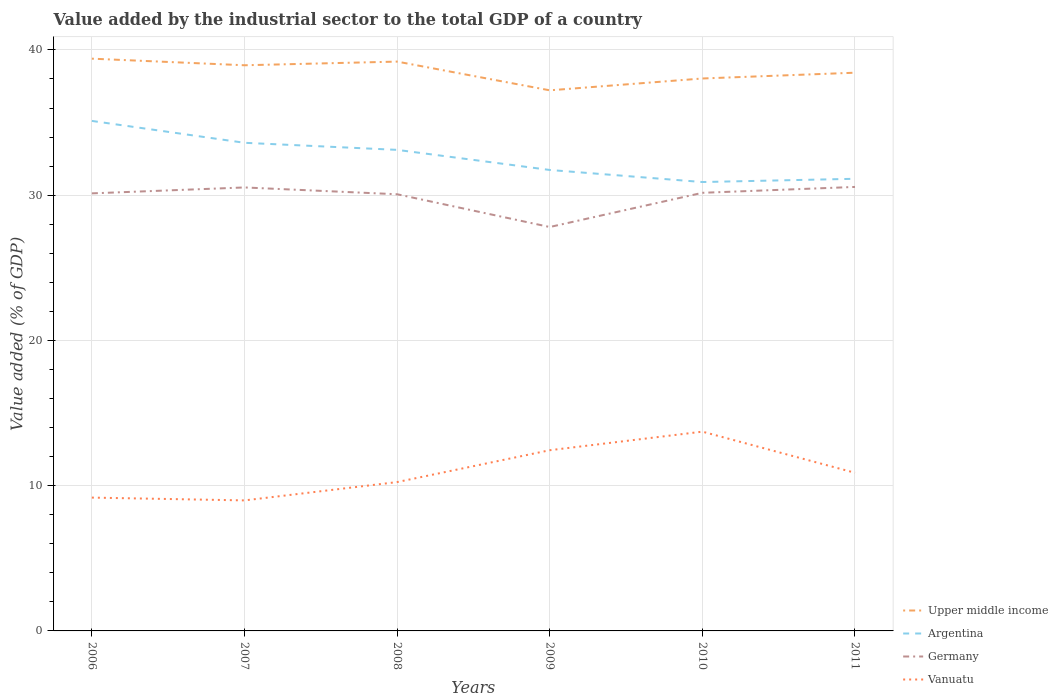Does the line corresponding to Argentina intersect with the line corresponding to Upper middle income?
Your response must be concise. No. Is the number of lines equal to the number of legend labels?
Offer a terse response. Yes. Across all years, what is the maximum value added by the industrial sector to the total GDP in Upper middle income?
Provide a succinct answer. 37.22. What is the total value added by the industrial sector to the total GDP in Upper middle income in the graph?
Your answer should be compact. 0.91. What is the difference between the highest and the second highest value added by the industrial sector to the total GDP in Upper middle income?
Ensure brevity in your answer.  2.18. Is the value added by the industrial sector to the total GDP in Germany strictly greater than the value added by the industrial sector to the total GDP in Argentina over the years?
Provide a succinct answer. Yes. How many lines are there?
Keep it short and to the point. 4. Are the values on the major ticks of Y-axis written in scientific E-notation?
Provide a succinct answer. No. Does the graph contain any zero values?
Your answer should be very brief. No. How many legend labels are there?
Ensure brevity in your answer.  4. What is the title of the graph?
Keep it short and to the point. Value added by the industrial sector to the total GDP of a country. What is the label or title of the X-axis?
Your response must be concise. Years. What is the label or title of the Y-axis?
Give a very brief answer. Value added (% of GDP). What is the Value added (% of GDP) of Upper middle income in 2006?
Offer a terse response. 39.4. What is the Value added (% of GDP) of Argentina in 2006?
Your answer should be very brief. 35.11. What is the Value added (% of GDP) in Germany in 2006?
Ensure brevity in your answer.  30.12. What is the Value added (% of GDP) in Vanuatu in 2006?
Your answer should be very brief. 9.18. What is the Value added (% of GDP) of Upper middle income in 2007?
Give a very brief answer. 38.94. What is the Value added (% of GDP) in Argentina in 2007?
Your response must be concise. 33.61. What is the Value added (% of GDP) in Germany in 2007?
Ensure brevity in your answer.  30.53. What is the Value added (% of GDP) in Vanuatu in 2007?
Your answer should be very brief. 8.99. What is the Value added (% of GDP) in Upper middle income in 2008?
Ensure brevity in your answer.  39.2. What is the Value added (% of GDP) in Argentina in 2008?
Your answer should be very brief. 33.12. What is the Value added (% of GDP) of Germany in 2008?
Offer a very short reply. 30.06. What is the Value added (% of GDP) in Vanuatu in 2008?
Keep it short and to the point. 10.25. What is the Value added (% of GDP) of Upper middle income in 2009?
Offer a very short reply. 37.22. What is the Value added (% of GDP) in Argentina in 2009?
Your answer should be very brief. 31.74. What is the Value added (% of GDP) in Germany in 2009?
Ensure brevity in your answer.  27.81. What is the Value added (% of GDP) of Vanuatu in 2009?
Give a very brief answer. 12.44. What is the Value added (% of GDP) of Upper middle income in 2010?
Keep it short and to the point. 38.03. What is the Value added (% of GDP) in Argentina in 2010?
Keep it short and to the point. 30.9. What is the Value added (% of GDP) of Germany in 2010?
Provide a short and direct response. 30.16. What is the Value added (% of GDP) in Vanuatu in 2010?
Offer a terse response. 13.72. What is the Value added (% of GDP) in Upper middle income in 2011?
Your answer should be compact. 38.43. What is the Value added (% of GDP) of Argentina in 2011?
Your answer should be compact. 31.13. What is the Value added (% of GDP) in Germany in 2011?
Make the answer very short. 30.57. What is the Value added (% of GDP) in Vanuatu in 2011?
Your answer should be compact. 10.89. Across all years, what is the maximum Value added (% of GDP) of Upper middle income?
Offer a very short reply. 39.4. Across all years, what is the maximum Value added (% of GDP) of Argentina?
Your answer should be compact. 35.11. Across all years, what is the maximum Value added (% of GDP) of Germany?
Give a very brief answer. 30.57. Across all years, what is the maximum Value added (% of GDP) of Vanuatu?
Ensure brevity in your answer.  13.72. Across all years, what is the minimum Value added (% of GDP) of Upper middle income?
Give a very brief answer. 37.22. Across all years, what is the minimum Value added (% of GDP) of Argentina?
Provide a succinct answer. 30.9. Across all years, what is the minimum Value added (% of GDP) of Germany?
Make the answer very short. 27.81. Across all years, what is the minimum Value added (% of GDP) in Vanuatu?
Ensure brevity in your answer.  8.99. What is the total Value added (% of GDP) in Upper middle income in the graph?
Your answer should be very brief. 231.22. What is the total Value added (% of GDP) of Argentina in the graph?
Provide a short and direct response. 195.6. What is the total Value added (% of GDP) in Germany in the graph?
Offer a very short reply. 179.26. What is the total Value added (% of GDP) of Vanuatu in the graph?
Provide a short and direct response. 65.46. What is the difference between the Value added (% of GDP) of Upper middle income in 2006 and that in 2007?
Provide a succinct answer. 0.45. What is the difference between the Value added (% of GDP) of Argentina in 2006 and that in 2007?
Keep it short and to the point. 1.51. What is the difference between the Value added (% of GDP) of Germany in 2006 and that in 2007?
Provide a short and direct response. -0.41. What is the difference between the Value added (% of GDP) of Vanuatu in 2006 and that in 2007?
Offer a terse response. 0.19. What is the difference between the Value added (% of GDP) in Upper middle income in 2006 and that in 2008?
Your response must be concise. 0.2. What is the difference between the Value added (% of GDP) of Argentina in 2006 and that in 2008?
Your answer should be compact. 1.99. What is the difference between the Value added (% of GDP) in Germany in 2006 and that in 2008?
Offer a very short reply. 0.06. What is the difference between the Value added (% of GDP) of Vanuatu in 2006 and that in 2008?
Offer a terse response. -1.07. What is the difference between the Value added (% of GDP) of Upper middle income in 2006 and that in 2009?
Offer a terse response. 2.18. What is the difference between the Value added (% of GDP) in Argentina in 2006 and that in 2009?
Your response must be concise. 3.38. What is the difference between the Value added (% of GDP) of Germany in 2006 and that in 2009?
Make the answer very short. 2.32. What is the difference between the Value added (% of GDP) in Vanuatu in 2006 and that in 2009?
Provide a short and direct response. -3.26. What is the difference between the Value added (% of GDP) in Upper middle income in 2006 and that in 2010?
Give a very brief answer. 1.36. What is the difference between the Value added (% of GDP) of Argentina in 2006 and that in 2010?
Give a very brief answer. 4.21. What is the difference between the Value added (% of GDP) in Germany in 2006 and that in 2010?
Make the answer very short. -0.04. What is the difference between the Value added (% of GDP) of Vanuatu in 2006 and that in 2010?
Keep it short and to the point. -4.54. What is the difference between the Value added (% of GDP) of Upper middle income in 2006 and that in 2011?
Give a very brief answer. 0.97. What is the difference between the Value added (% of GDP) of Argentina in 2006 and that in 2011?
Offer a very short reply. 3.98. What is the difference between the Value added (% of GDP) of Germany in 2006 and that in 2011?
Ensure brevity in your answer.  -0.44. What is the difference between the Value added (% of GDP) of Vanuatu in 2006 and that in 2011?
Your answer should be compact. -1.71. What is the difference between the Value added (% of GDP) of Upper middle income in 2007 and that in 2008?
Ensure brevity in your answer.  -0.25. What is the difference between the Value added (% of GDP) in Argentina in 2007 and that in 2008?
Offer a very short reply. 0.49. What is the difference between the Value added (% of GDP) of Germany in 2007 and that in 2008?
Provide a short and direct response. 0.47. What is the difference between the Value added (% of GDP) in Vanuatu in 2007 and that in 2008?
Make the answer very short. -1.26. What is the difference between the Value added (% of GDP) of Upper middle income in 2007 and that in 2009?
Ensure brevity in your answer.  1.73. What is the difference between the Value added (% of GDP) in Argentina in 2007 and that in 2009?
Give a very brief answer. 1.87. What is the difference between the Value added (% of GDP) in Germany in 2007 and that in 2009?
Offer a terse response. 2.72. What is the difference between the Value added (% of GDP) of Vanuatu in 2007 and that in 2009?
Provide a succinct answer. -3.45. What is the difference between the Value added (% of GDP) in Upper middle income in 2007 and that in 2010?
Offer a very short reply. 0.91. What is the difference between the Value added (% of GDP) of Argentina in 2007 and that in 2010?
Make the answer very short. 2.7. What is the difference between the Value added (% of GDP) of Germany in 2007 and that in 2010?
Keep it short and to the point. 0.37. What is the difference between the Value added (% of GDP) in Vanuatu in 2007 and that in 2010?
Ensure brevity in your answer.  -4.73. What is the difference between the Value added (% of GDP) of Upper middle income in 2007 and that in 2011?
Provide a succinct answer. 0.51. What is the difference between the Value added (% of GDP) of Argentina in 2007 and that in 2011?
Your answer should be compact. 2.48. What is the difference between the Value added (% of GDP) in Germany in 2007 and that in 2011?
Give a very brief answer. -0.04. What is the difference between the Value added (% of GDP) of Vanuatu in 2007 and that in 2011?
Your answer should be very brief. -1.9. What is the difference between the Value added (% of GDP) in Upper middle income in 2008 and that in 2009?
Keep it short and to the point. 1.98. What is the difference between the Value added (% of GDP) of Argentina in 2008 and that in 2009?
Ensure brevity in your answer.  1.38. What is the difference between the Value added (% of GDP) of Germany in 2008 and that in 2009?
Provide a succinct answer. 2.26. What is the difference between the Value added (% of GDP) of Vanuatu in 2008 and that in 2009?
Provide a succinct answer. -2.19. What is the difference between the Value added (% of GDP) in Upper middle income in 2008 and that in 2010?
Ensure brevity in your answer.  1.16. What is the difference between the Value added (% of GDP) of Argentina in 2008 and that in 2010?
Give a very brief answer. 2.22. What is the difference between the Value added (% of GDP) of Germany in 2008 and that in 2010?
Keep it short and to the point. -0.1. What is the difference between the Value added (% of GDP) in Vanuatu in 2008 and that in 2010?
Give a very brief answer. -3.47. What is the difference between the Value added (% of GDP) of Upper middle income in 2008 and that in 2011?
Give a very brief answer. 0.76. What is the difference between the Value added (% of GDP) in Argentina in 2008 and that in 2011?
Your answer should be compact. 1.99. What is the difference between the Value added (% of GDP) of Germany in 2008 and that in 2011?
Keep it short and to the point. -0.5. What is the difference between the Value added (% of GDP) of Vanuatu in 2008 and that in 2011?
Make the answer very short. -0.64. What is the difference between the Value added (% of GDP) in Upper middle income in 2009 and that in 2010?
Your answer should be very brief. -0.82. What is the difference between the Value added (% of GDP) of Argentina in 2009 and that in 2010?
Ensure brevity in your answer.  0.83. What is the difference between the Value added (% of GDP) in Germany in 2009 and that in 2010?
Your response must be concise. -2.35. What is the difference between the Value added (% of GDP) in Vanuatu in 2009 and that in 2010?
Offer a terse response. -1.28. What is the difference between the Value added (% of GDP) of Upper middle income in 2009 and that in 2011?
Your answer should be very brief. -1.21. What is the difference between the Value added (% of GDP) of Argentina in 2009 and that in 2011?
Offer a terse response. 0.61. What is the difference between the Value added (% of GDP) of Germany in 2009 and that in 2011?
Offer a very short reply. -2.76. What is the difference between the Value added (% of GDP) in Vanuatu in 2009 and that in 2011?
Your answer should be compact. 1.55. What is the difference between the Value added (% of GDP) of Upper middle income in 2010 and that in 2011?
Your response must be concise. -0.4. What is the difference between the Value added (% of GDP) in Argentina in 2010 and that in 2011?
Offer a terse response. -0.22. What is the difference between the Value added (% of GDP) of Germany in 2010 and that in 2011?
Keep it short and to the point. -0.4. What is the difference between the Value added (% of GDP) in Vanuatu in 2010 and that in 2011?
Your response must be concise. 2.83. What is the difference between the Value added (% of GDP) of Upper middle income in 2006 and the Value added (% of GDP) of Argentina in 2007?
Offer a terse response. 5.79. What is the difference between the Value added (% of GDP) of Upper middle income in 2006 and the Value added (% of GDP) of Germany in 2007?
Your answer should be compact. 8.87. What is the difference between the Value added (% of GDP) of Upper middle income in 2006 and the Value added (% of GDP) of Vanuatu in 2007?
Keep it short and to the point. 30.41. What is the difference between the Value added (% of GDP) of Argentina in 2006 and the Value added (% of GDP) of Germany in 2007?
Ensure brevity in your answer.  4.58. What is the difference between the Value added (% of GDP) of Argentina in 2006 and the Value added (% of GDP) of Vanuatu in 2007?
Provide a short and direct response. 26.13. What is the difference between the Value added (% of GDP) of Germany in 2006 and the Value added (% of GDP) of Vanuatu in 2007?
Ensure brevity in your answer.  21.14. What is the difference between the Value added (% of GDP) of Upper middle income in 2006 and the Value added (% of GDP) of Argentina in 2008?
Provide a short and direct response. 6.28. What is the difference between the Value added (% of GDP) of Upper middle income in 2006 and the Value added (% of GDP) of Germany in 2008?
Offer a very short reply. 9.33. What is the difference between the Value added (% of GDP) of Upper middle income in 2006 and the Value added (% of GDP) of Vanuatu in 2008?
Provide a short and direct response. 29.15. What is the difference between the Value added (% of GDP) of Argentina in 2006 and the Value added (% of GDP) of Germany in 2008?
Keep it short and to the point. 5.05. What is the difference between the Value added (% of GDP) in Argentina in 2006 and the Value added (% of GDP) in Vanuatu in 2008?
Your answer should be compact. 24.86. What is the difference between the Value added (% of GDP) in Germany in 2006 and the Value added (% of GDP) in Vanuatu in 2008?
Give a very brief answer. 19.88. What is the difference between the Value added (% of GDP) in Upper middle income in 2006 and the Value added (% of GDP) in Argentina in 2009?
Offer a terse response. 7.66. What is the difference between the Value added (% of GDP) in Upper middle income in 2006 and the Value added (% of GDP) in Germany in 2009?
Offer a very short reply. 11.59. What is the difference between the Value added (% of GDP) of Upper middle income in 2006 and the Value added (% of GDP) of Vanuatu in 2009?
Your answer should be very brief. 26.96. What is the difference between the Value added (% of GDP) in Argentina in 2006 and the Value added (% of GDP) in Germany in 2009?
Make the answer very short. 7.3. What is the difference between the Value added (% of GDP) of Argentina in 2006 and the Value added (% of GDP) of Vanuatu in 2009?
Your answer should be very brief. 22.67. What is the difference between the Value added (% of GDP) in Germany in 2006 and the Value added (% of GDP) in Vanuatu in 2009?
Your answer should be compact. 17.68. What is the difference between the Value added (% of GDP) of Upper middle income in 2006 and the Value added (% of GDP) of Argentina in 2010?
Make the answer very short. 8.49. What is the difference between the Value added (% of GDP) of Upper middle income in 2006 and the Value added (% of GDP) of Germany in 2010?
Your answer should be compact. 9.24. What is the difference between the Value added (% of GDP) of Upper middle income in 2006 and the Value added (% of GDP) of Vanuatu in 2010?
Ensure brevity in your answer.  25.68. What is the difference between the Value added (% of GDP) of Argentina in 2006 and the Value added (% of GDP) of Germany in 2010?
Provide a succinct answer. 4.95. What is the difference between the Value added (% of GDP) in Argentina in 2006 and the Value added (% of GDP) in Vanuatu in 2010?
Ensure brevity in your answer.  21.39. What is the difference between the Value added (% of GDP) of Germany in 2006 and the Value added (% of GDP) of Vanuatu in 2010?
Provide a short and direct response. 16.4. What is the difference between the Value added (% of GDP) in Upper middle income in 2006 and the Value added (% of GDP) in Argentina in 2011?
Your answer should be very brief. 8.27. What is the difference between the Value added (% of GDP) in Upper middle income in 2006 and the Value added (% of GDP) in Germany in 2011?
Keep it short and to the point. 8.83. What is the difference between the Value added (% of GDP) in Upper middle income in 2006 and the Value added (% of GDP) in Vanuatu in 2011?
Keep it short and to the point. 28.51. What is the difference between the Value added (% of GDP) of Argentina in 2006 and the Value added (% of GDP) of Germany in 2011?
Your answer should be very brief. 4.54. What is the difference between the Value added (% of GDP) of Argentina in 2006 and the Value added (% of GDP) of Vanuatu in 2011?
Make the answer very short. 24.23. What is the difference between the Value added (% of GDP) in Germany in 2006 and the Value added (% of GDP) in Vanuatu in 2011?
Ensure brevity in your answer.  19.24. What is the difference between the Value added (% of GDP) of Upper middle income in 2007 and the Value added (% of GDP) of Argentina in 2008?
Ensure brevity in your answer.  5.82. What is the difference between the Value added (% of GDP) of Upper middle income in 2007 and the Value added (% of GDP) of Germany in 2008?
Your answer should be compact. 8.88. What is the difference between the Value added (% of GDP) in Upper middle income in 2007 and the Value added (% of GDP) in Vanuatu in 2008?
Keep it short and to the point. 28.7. What is the difference between the Value added (% of GDP) in Argentina in 2007 and the Value added (% of GDP) in Germany in 2008?
Your answer should be very brief. 3.54. What is the difference between the Value added (% of GDP) in Argentina in 2007 and the Value added (% of GDP) in Vanuatu in 2008?
Provide a succinct answer. 23.36. What is the difference between the Value added (% of GDP) of Germany in 2007 and the Value added (% of GDP) of Vanuatu in 2008?
Offer a terse response. 20.28. What is the difference between the Value added (% of GDP) of Upper middle income in 2007 and the Value added (% of GDP) of Argentina in 2009?
Provide a short and direct response. 7.21. What is the difference between the Value added (% of GDP) of Upper middle income in 2007 and the Value added (% of GDP) of Germany in 2009?
Your answer should be compact. 11.14. What is the difference between the Value added (% of GDP) of Upper middle income in 2007 and the Value added (% of GDP) of Vanuatu in 2009?
Offer a very short reply. 26.5. What is the difference between the Value added (% of GDP) in Argentina in 2007 and the Value added (% of GDP) in Germany in 2009?
Your response must be concise. 5.8. What is the difference between the Value added (% of GDP) of Argentina in 2007 and the Value added (% of GDP) of Vanuatu in 2009?
Keep it short and to the point. 21.16. What is the difference between the Value added (% of GDP) in Germany in 2007 and the Value added (% of GDP) in Vanuatu in 2009?
Provide a short and direct response. 18.09. What is the difference between the Value added (% of GDP) of Upper middle income in 2007 and the Value added (% of GDP) of Argentina in 2010?
Make the answer very short. 8.04. What is the difference between the Value added (% of GDP) in Upper middle income in 2007 and the Value added (% of GDP) in Germany in 2010?
Your answer should be very brief. 8.78. What is the difference between the Value added (% of GDP) of Upper middle income in 2007 and the Value added (% of GDP) of Vanuatu in 2010?
Give a very brief answer. 25.22. What is the difference between the Value added (% of GDP) of Argentina in 2007 and the Value added (% of GDP) of Germany in 2010?
Keep it short and to the point. 3.44. What is the difference between the Value added (% of GDP) of Argentina in 2007 and the Value added (% of GDP) of Vanuatu in 2010?
Your response must be concise. 19.89. What is the difference between the Value added (% of GDP) of Germany in 2007 and the Value added (% of GDP) of Vanuatu in 2010?
Keep it short and to the point. 16.81. What is the difference between the Value added (% of GDP) of Upper middle income in 2007 and the Value added (% of GDP) of Argentina in 2011?
Provide a short and direct response. 7.82. What is the difference between the Value added (% of GDP) of Upper middle income in 2007 and the Value added (% of GDP) of Germany in 2011?
Offer a very short reply. 8.38. What is the difference between the Value added (% of GDP) of Upper middle income in 2007 and the Value added (% of GDP) of Vanuatu in 2011?
Your answer should be very brief. 28.06. What is the difference between the Value added (% of GDP) in Argentina in 2007 and the Value added (% of GDP) in Germany in 2011?
Keep it short and to the point. 3.04. What is the difference between the Value added (% of GDP) of Argentina in 2007 and the Value added (% of GDP) of Vanuatu in 2011?
Ensure brevity in your answer.  22.72. What is the difference between the Value added (% of GDP) in Germany in 2007 and the Value added (% of GDP) in Vanuatu in 2011?
Your answer should be compact. 19.65. What is the difference between the Value added (% of GDP) in Upper middle income in 2008 and the Value added (% of GDP) in Argentina in 2009?
Give a very brief answer. 7.46. What is the difference between the Value added (% of GDP) of Upper middle income in 2008 and the Value added (% of GDP) of Germany in 2009?
Provide a short and direct response. 11.39. What is the difference between the Value added (% of GDP) in Upper middle income in 2008 and the Value added (% of GDP) in Vanuatu in 2009?
Provide a succinct answer. 26.76. What is the difference between the Value added (% of GDP) in Argentina in 2008 and the Value added (% of GDP) in Germany in 2009?
Ensure brevity in your answer.  5.31. What is the difference between the Value added (% of GDP) of Argentina in 2008 and the Value added (% of GDP) of Vanuatu in 2009?
Your response must be concise. 20.68. What is the difference between the Value added (% of GDP) in Germany in 2008 and the Value added (% of GDP) in Vanuatu in 2009?
Give a very brief answer. 17.62. What is the difference between the Value added (% of GDP) of Upper middle income in 2008 and the Value added (% of GDP) of Argentina in 2010?
Offer a terse response. 8.29. What is the difference between the Value added (% of GDP) in Upper middle income in 2008 and the Value added (% of GDP) in Germany in 2010?
Give a very brief answer. 9.03. What is the difference between the Value added (% of GDP) of Upper middle income in 2008 and the Value added (% of GDP) of Vanuatu in 2010?
Your answer should be very brief. 25.48. What is the difference between the Value added (% of GDP) of Argentina in 2008 and the Value added (% of GDP) of Germany in 2010?
Give a very brief answer. 2.96. What is the difference between the Value added (% of GDP) of Argentina in 2008 and the Value added (% of GDP) of Vanuatu in 2010?
Offer a very short reply. 19.4. What is the difference between the Value added (% of GDP) in Germany in 2008 and the Value added (% of GDP) in Vanuatu in 2010?
Give a very brief answer. 16.34. What is the difference between the Value added (% of GDP) in Upper middle income in 2008 and the Value added (% of GDP) in Argentina in 2011?
Provide a succinct answer. 8.07. What is the difference between the Value added (% of GDP) of Upper middle income in 2008 and the Value added (% of GDP) of Germany in 2011?
Provide a short and direct response. 8.63. What is the difference between the Value added (% of GDP) in Upper middle income in 2008 and the Value added (% of GDP) in Vanuatu in 2011?
Keep it short and to the point. 28.31. What is the difference between the Value added (% of GDP) of Argentina in 2008 and the Value added (% of GDP) of Germany in 2011?
Give a very brief answer. 2.55. What is the difference between the Value added (% of GDP) in Argentina in 2008 and the Value added (% of GDP) in Vanuatu in 2011?
Provide a short and direct response. 22.23. What is the difference between the Value added (% of GDP) of Germany in 2008 and the Value added (% of GDP) of Vanuatu in 2011?
Keep it short and to the point. 19.18. What is the difference between the Value added (% of GDP) of Upper middle income in 2009 and the Value added (% of GDP) of Argentina in 2010?
Offer a terse response. 6.31. What is the difference between the Value added (% of GDP) in Upper middle income in 2009 and the Value added (% of GDP) in Germany in 2010?
Make the answer very short. 7.06. What is the difference between the Value added (% of GDP) in Upper middle income in 2009 and the Value added (% of GDP) in Vanuatu in 2010?
Your response must be concise. 23.5. What is the difference between the Value added (% of GDP) of Argentina in 2009 and the Value added (% of GDP) of Germany in 2010?
Ensure brevity in your answer.  1.57. What is the difference between the Value added (% of GDP) of Argentina in 2009 and the Value added (% of GDP) of Vanuatu in 2010?
Make the answer very short. 18.02. What is the difference between the Value added (% of GDP) in Germany in 2009 and the Value added (% of GDP) in Vanuatu in 2010?
Your response must be concise. 14.09. What is the difference between the Value added (% of GDP) in Upper middle income in 2009 and the Value added (% of GDP) in Argentina in 2011?
Your answer should be very brief. 6.09. What is the difference between the Value added (% of GDP) in Upper middle income in 2009 and the Value added (% of GDP) in Germany in 2011?
Offer a terse response. 6.65. What is the difference between the Value added (% of GDP) in Upper middle income in 2009 and the Value added (% of GDP) in Vanuatu in 2011?
Your answer should be very brief. 26.33. What is the difference between the Value added (% of GDP) of Argentina in 2009 and the Value added (% of GDP) of Germany in 2011?
Ensure brevity in your answer.  1.17. What is the difference between the Value added (% of GDP) of Argentina in 2009 and the Value added (% of GDP) of Vanuatu in 2011?
Provide a succinct answer. 20.85. What is the difference between the Value added (% of GDP) in Germany in 2009 and the Value added (% of GDP) in Vanuatu in 2011?
Your answer should be very brief. 16.92. What is the difference between the Value added (% of GDP) of Upper middle income in 2010 and the Value added (% of GDP) of Argentina in 2011?
Provide a succinct answer. 6.91. What is the difference between the Value added (% of GDP) in Upper middle income in 2010 and the Value added (% of GDP) in Germany in 2011?
Give a very brief answer. 7.47. What is the difference between the Value added (% of GDP) of Upper middle income in 2010 and the Value added (% of GDP) of Vanuatu in 2011?
Your response must be concise. 27.15. What is the difference between the Value added (% of GDP) in Argentina in 2010 and the Value added (% of GDP) in Germany in 2011?
Keep it short and to the point. 0.34. What is the difference between the Value added (% of GDP) of Argentina in 2010 and the Value added (% of GDP) of Vanuatu in 2011?
Offer a terse response. 20.02. What is the difference between the Value added (% of GDP) in Germany in 2010 and the Value added (% of GDP) in Vanuatu in 2011?
Provide a succinct answer. 19.28. What is the average Value added (% of GDP) in Upper middle income per year?
Give a very brief answer. 38.54. What is the average Value added (% of GDP) in Argentina per year?
Provide a succinct answer. 32.6. What is the average Value added (% of GDP) of Germany per year?
Keep it short and to the point. 29.88. What is the average Value added (% of GDP) in Vanuatu per year?
Provide a succinct answer. 10.91. In the year 2006, what is the difference between the Value added (% of GDP) of Upper middle income and Value added (% of GDP) of Argentina?
Ensure brevity in your answer.  4.29. In the year 2006, what is the difference between the Value added (% of GDP) of Upper middle income and Value added (% of GDP) of Germany?
Provide a succinct answer. 9.27. In the year 2006, what is the difference between the Value added (% of GDP) of Upper middle income and Value added (% of GDP) of Vanuatu?
Offer a terse response. 30.22. In the year 2006, what is the difference between the Value added (% of GDP) of Argentina and Value added (% of GDP) of Germany?
Give a very brief answer. 4.99. In the year 2006, what is the difference between the Value added (% of GDP) of Argentina and Value added (% of GDP) of Vanuatu?
Your response must be concise. 25.93. In the year 2006, what is the difference between the Value added (% of GDP) in Germany and Value added (% of GDP) in Vanuatu?
Provide a short and direct response. 20.95. In the year 2007, what is the difference between the Value added (% of GDP) in Upper middle income and Value added (% of GDP) in Argentina?
Offer a very short reply. 5.34. In the year 2007, what is the difference between the Value added (% of GDP) in Upper middle income and Value added (% of GDP) in Germany?
Make the answer very short. 8.41. In the year 2007, what is the difference between the Value added (% of GDP) in Upper middle income and Value added (% of GDP) in Vanuatu?
Make the answer very short. 29.96. In the year 2007, what is the difference between the Value added (% of GDP) in Argentina and Value added (% of GDP) in Germany?
Offer a very short reply. 3.07. In the year 2007, what is the difference between the Value added (% of GDP) in Argentina and Value added (% of GDP) in Vanuatu?
Your response must be concise. 24.62. In the year 2007, what is the difference between the Value added (% of GDP) in Germany and Value added (% of GDP) in Vanuatu?
Ensure brevity in your answer.  21.55. In the year 2008, what is the difference between the Value added (% of GDP) in Upper middle income and Value added (% of GDP) in Argentina?
Offer a terse response. 6.08. In the year 2008, what is the difference between the Value added (% of GDP) of Upper middle income and Value added (% of GDP) of Germany?
Offer a terse response. 9.13. In the year 2008, what is the difference between the Value added (% of GDP) of Upper middle income and Value added (% of GDP) of Vanuatu?
Offer a terse response. 28.95. In the year 2008, what is the difference between the Value added (% of GDP) of Argentina and Value added (% of GDP) of Germany?
Provide a succinct answer. 3.06. In the year 2008, what is the difference between the Value added (% of GDP) in Argentina and Value added (% of GDP) in Vanuatu?
Provide a short and direct response. 22.87. In the year 2008, what is the difference between the Value added (% of GDP) of Germany and Value added (% of GDP) of Vanuatu?
Keep it short and to the point. 19.82. In the year 2009, what is the difference between the Value added (% of GDP) of Upper middle income and Value added (% of GDP) of Argentina?
Your answer should be very brief. 5.48. In the year 2009, what is the difference between the Value added (% of GDP) in Upper middle income and Value added (% of GDP) in Germany?
Ensure brevity in your answer.  9.41. In the year 2009, what is the difference between the Value added (% of GDP) in Upper middle income and Value added (% of GDP) in Vanuatu?
Your answer should be compact. 24.78. In the year 2009, what is the difference between the Value added (% of GDP) in Argentina and Value added (% of GDP) in Germany?
Give a very brief answer. 3.93. In the year 2009, what is the difference between the Value added (% of GDP) of Argentina and Value added (% of GDP) of Vanuatu?
Provide a short and direct response. 19.29. In the year 2009, what is the difference between the Value added (% of GDP) of Germany and Value added (% of GDP) of Vanuatu?
Make the answer very short. 15.37. In the year 2010, what is the difference between the Value added (% of GDP) of Upper middle income and Value added (% of GDP) of Argentina?
Offer a terse response. 7.13. In the year 2010, what is the difference between the Value added (% of GDP) in Upper middle income and Value added (% of GDP) in Germany?
Your answer should be very brief. 7.87. In the year 2010, what is the difference between the Value added (% of GDP) in Upper middle income and Value added (% of GDP) in Vanuatu?
Make the answer very short. 24.31. In the year 2010, what is the difference between the Value added (% of GDP) of Argentina and Value added (% of GDP) of Germany?
Ensure brevity in your answer.  0.74. In the year 2010, what is the difference between the Value added (% of GDP) of Argentina and Value added (% of GDP) of Vanuatu?
Ensure brevity in your answer.  17.18. In the year 2010, what is the difference between the Value added (% of GDP) in Germany and Value added (% of GDP) in Vanuatu?
Provide a succinct answer. 16.44. In the year 2011, what is the difference between the Value added (% of GDP) in Upper middle income and Value added (% of GDP) in Argentina?
Your response must be concise. 7.3. In the year 2011, what is the difference between the Value added (% of GDP) in Upper middle income and Value added (% of GDP) in Germany?
Offer a terse response. 7.86. In the year 2011, what is the difference between the Value added (% of GDP) in Upper middle income and Value added (% of GDP) in Vanuatu?
Keep it short and to the point. 27.55. In the year 2011, what is the difference between the Value added (% of GDP) in Argentina and Value added (% of GDP) in Germany?
Offer a very short reply. 0.56. In the year 2011, what is the difference between the Value added (% of GDP) of Argentina and Value added (% of GDP) of Vanuatu?
Offer a terse response. 20.24. In the year 2011, what is the difference between the Value added (% of GDP) in Germany and Value added (% of GDP) in Vanuatu?
Ensure brevity in your answer.  19.68. What is the ratio of the Value added (% of GDP) of Upper middle income in 2006 to that in 2007?
Offer a very short reply. 1.01. What is the ratio of the Value added (% of GDP) in Argentina in 2006 to that in 2007?
Offer a very short reply. 1.04. What is the ratio of the Value added (% of GDP) in Germany in 2006 to that in 2007?
Give a very brief answer. 0.99. What is the ratio of the Value added (% of GDP) in Vanuatu in 2006 to that in 2007?
Provide a short and direct response. 1.02. What is the ratio of the Value added (% of GDP) of Upper middle income in 2006 to that in 2008?
Keep it short and to the point. 1.01. What is the ratio of the Value added (% of GDP) in Argentina in 2006 to that in 2008?
Make the answer very short. 1.06. What is the ratio of the Value added (% of GDP) of Vanuatu in 2006 to that in 2008?
Ensure brevity in your answer.  0.9. What is the ratio of the Value added (% of GDP) in Upper middle income in 2006 to that in 2009?
Your answer should be compact. 1.06. What is the ratio of the Value added (% of GDP) in Argentina in 2006 to that in 2009?
Your response must be concise. 1.11. What is the ratio of the Value added (% of GDP) of Vanuatu in 2006 to that in 2009?
Offer a terse response. 0.74. What is the ratio of the Value added (% of GDP) of Upper middle income in 2006 to that in 2010?
Your answer should be very brief. 1.04. What is the ratio of the Value added (% of GDP) in Argentina in 2006 to that in 2010?
Offer a terse response. 1.14. What is the ratio of the Value added (% of GDP) of Germany in 2006 to that in 2010?
Make the answer very short. 1. What is the ratio of the Value added (% of GDP) of Vanuatu in 2006 to that in 2010?
Your answer should be compact. 0.67. What is the ratio of the Value added (% of GDP) in Upper middle income in 2006 to that in 2011?
Provide a short and direct response. 1.03. What is the ratio of the Value added (% of GDP) of Argentina in 2006 to that in 2011?
Provide a short and direct response. 1.13. What is the ratio of the Value added (% of GDP) in Germany in 2006 to that in 2011?
Your response must be concise. 0.99. What is the ratio of the Value added (% of GDP) of Vanuatu in 2006 to that in 2011?
Provide a short and direct response. 0.84. What is the ratio of the Value added (% of GDP) in Upper middle income in 2007 to that in 2008?
Your answer should be very brief. 0.99. What is the ratio of the Value added (% of GDP) in Argentina in 2007 to that in 2008?
Keep it short and to the point. 1.01. What is the ratio of the Value added (% of GDP) of Germany in 2007 to that in 2008?
Offer a very short reply. 1.02. What is the ratio of the Value added (% of GDP) in Vanuatu in 2007 to that in 2008?
Your answer should be compact. 0.88. What is the ratio of the Value added (% of GDP) of Upper middle income in 2007 to that in 2009?
Give a very brief answer. 1.05. What is the ratio of the Value added (% of GDP) of Argentina in 2007 to that in 2009?
Offer a terse response. 1.06. What is the ratio of the Value added (% of GDP) of Germany in 2007 to that in 2009?
Your response must be concise. 1.1. What is the ratio of the Value added (% of GDP) in Vanuatu in 2007 to that in 2009?
Make the answer very short. 0.72. What is the ratio of the Value added (% of GDP) of Upper middle income in 2007 to that in 2010?
Your answer should be compact. 1.02. What is the ratio of the Value added (% of GDP) in Argentina in 2007 to that in 2010?
Provide a succinct answer. 1.09. What is the ratio of the Value added (% of GDP) in Germany in 2007 to that in 2010?
Provide a succinct answer. 1.01. What is the ratio of the Value added (% of GDP) in Vanuatu in 2007 to that in 2010?
Your answer should be compact. 0.66. What is the ratio of the Value added (% of GDP) of Upper middle income in 2007 to that in 2011?
Provide a short and direct response. 1.01. What is the ratio of the Value added (% of GDP) of Argentina in 2007 to that in 2011?
Your answer should be compact. 1.08. What is the ratio of the Value added (% of GDP) in Vanuatu in 2007 to that in 2011?
Ensure brevity in your answer.  0.83. What is the ratio of the Value added (% of GDP) of Upper middle income in 2008 to that in 2009?
Give a very brief answer. 1.05. What is the ratio of the Value added (% of GDP) of Argentina in 2008 to that in 2009?
Give a very brief answer. 1.04. What is the ratio of the Value added (% of GDP) of Germany in 2008 to that in 2009?
Ensure brevity in your answer.  1.08. What is the ratio of the Value added (% of GDP) in Vanuatu in 2008 to that in 2009?
Your answer should be compact. 0.82. What is the ratio of the Value added (% of GDP) of Upper middle income in 2008 to that in 2010?
Keep it short and to the point. 1.03. What is the ratio of the Value added (% of GDP) of Argentina in 2008 to that in 2010?
Provide a short and direct response. 1.07. What is the ratio of the Value added (% of GDP) in Vanuatu in 2008 to that in 2010?
Give a very brief answer. 0.75. What is the ratio of the Value added (% of GDP) in Upper middle income in 2008 to that in 2011?
Keep it short and to the point. 1.02. What is the ratio of the Value added (% of GDP) of Argentina in 2008 to that in 2011?
Give a very brief answer. 1.06. What is the ratio of the Value added (% of GDP) of Germany in 2008 to that in 2011?
Your response must be concise. 0.98. What is the ratio of the Value added (% of GDP) of Vanuatu in 2008 to that in 2011?
Keep it short and to the point. 0.94. What is the ratio of the Value added (% of GDP) in Upper middle income in 2009 to that in 2010?
Give a very brief answer. 0.98. What is the ratio of the Value added (% of GDP) in Argentina in 2009 to that in 2010?
Make the answer very short. 1.03. What is the ratio of the Value added (% of GDP) in Germany in 2009 to that in 2010?
Your answer should be compact. 0.92. What is the ratio of the Value added (% of GDP) of Vanuatu in 2009 to that in 2010?
Ensure brevity in your answer.  0.91. What is the ratio of the Value added (% of GDP) in Upper middle income in 2009 to that in 2011?
Offer a terse response. 0.97. What is the ratio of the Value added (% of GDP) of Argentina in 2009 to that in 2011?
Provide a succinct answer. 1.02. What is the ratio of the Value added (% of GDP) in Germany in 2009 to that in 2011?
Provide a succinct answer. 0.91. What is the ratio of the Value added (% of GDP) of Vanuatu in 2009 to that in 2011?
Your answer should be compact. 1.14. What is the ratio of the Value added (% of GDP) of Upper middle income in 2010 to that in 2011?
Your response must be concise. 0.99. What is the ratio of the Value added (% of GDP) of Argentina in 2010 to that in 2011?
Provide a succinct answer. 0.99. What is the ratio of the Value added (% of GDP) of Vanuatu in 2010 to that in 2011?
Provide a short and direct response. 1.26. What is the difference between the highest and the second highest Value added (% of GDP) in Upper middle income?
Provide a succinct answer. 0.2. What is the difference between the highest and the second highest Value added (% of GDP) in Argentina?
Give a very brief answer. 1.51. What is the difference between the highest and the second highest Value added (% of GDP) in Germany?
Your answer should be very brief. 0.04. What is the difference between the highest and the second highest Value added (% of GDP) of Vanuatu?
Ensure brevity in your answer.  1.28. What is the difference between the highest and the lowest Value added (% of GDP) of Upper middle income?
Ensure brevity in your answer.  2.18. What is the difference between the highest and the lowest Value added (% of GDP) of Argentina?
Ensure brevity in your answer.  4.21. What is the difference between the highest and the lowest Value added (% of GDP) in Germany?
Your response must be concise. 2.76. What is the difference between the highest and the lowest Value added (% of GDP) in Vanuatu?
Offer a very short reply. 4.73. 